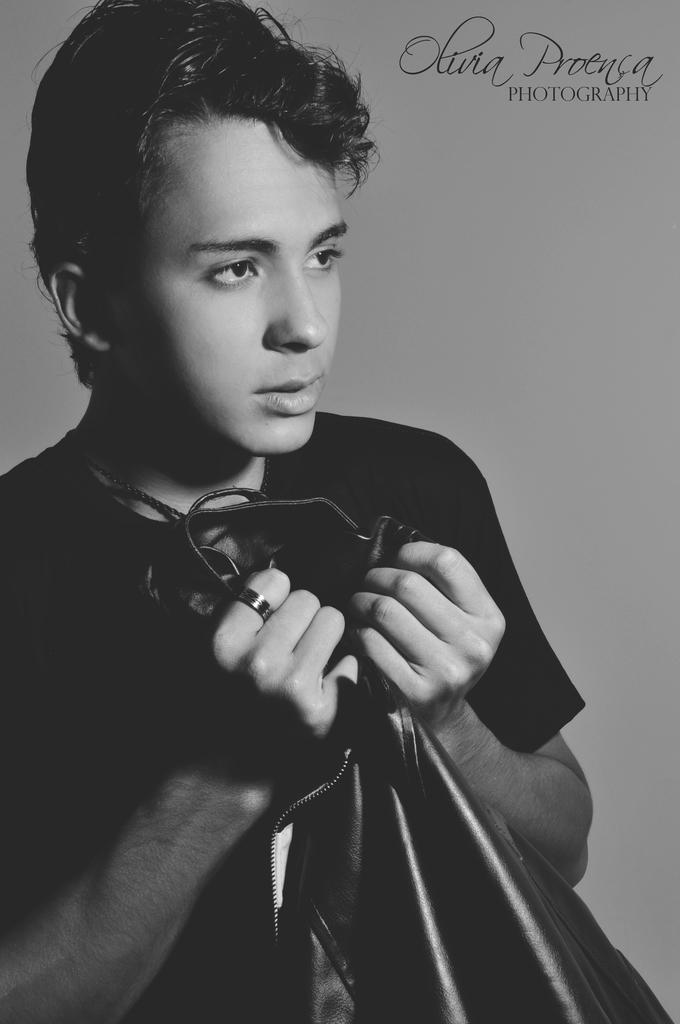Who is the main subject in the image? There is a boy in the image. What is the boy wearing? The boy is wearing a t-shirt. What is the boy holding in the image? The boy is holding a jacket with both hands. What can be seen in the background of the image? There is a wall in the background of the image. What advice does the police officer give the boy in the image? There is no police officer present in the image, so no advice can be given. How many fingers does the boy have in the image? The number of fingers the boy has cannot be determined from the image alone, as it does not show his hands in detail. 